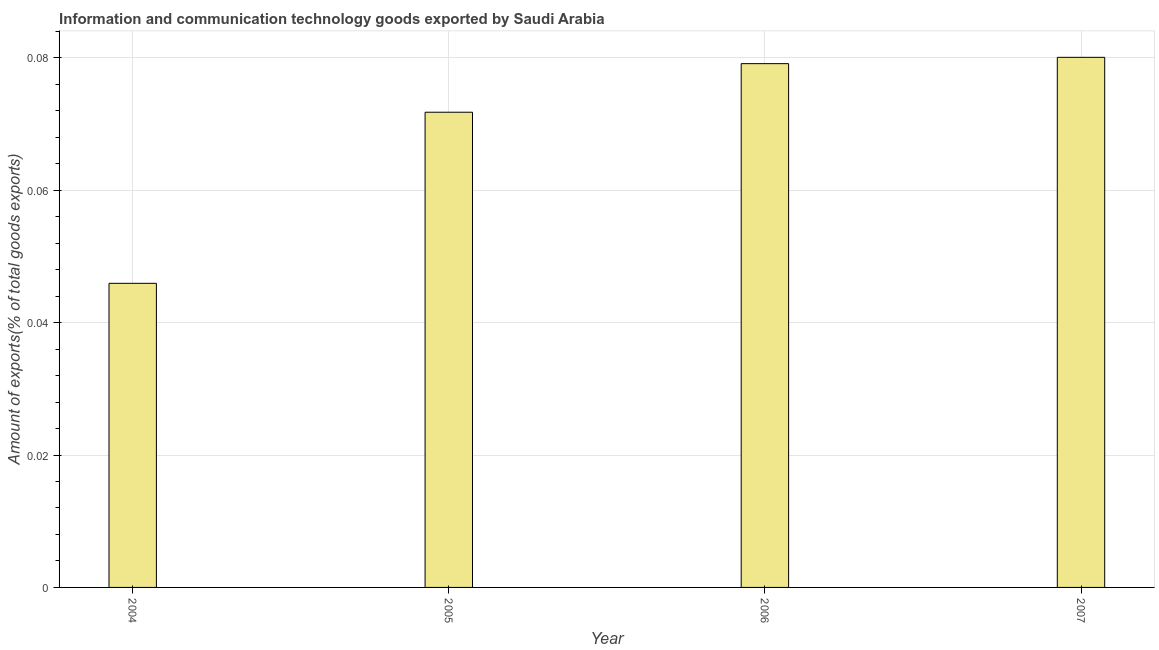Does the graph contain any zero values?
Your response must be concise. No. Does the graph contain grids?
Make the answer very short. Yes. What is the title of the graph?
Keep it short and to the point. Information and communication technology goods exported by Saudi Arabia. What is the label or title of the Y-axis?
Ensure brevity in your answer.  Amount of exports(% of total goods exports). What is the amount of ict goods exports in 2005?
Your answer should be compact. 0.07. Across all years, what is the maximum amount of ict goods exports?
Your response must be concise. 0.08. Across all years, what is the minimum amount of ict goods exports?
Ensure brevity in your answer.  0.05. In which year was the amount of ict goods exports maximum?
Provide a short and direct response. 2007. What is the sum of the amount of ict goods exports?
Make the answer very short. 0.28. What is the difference between the amount of ict goods exports in 2005 and 2007?
Offer a terse response. -0.01. What is the average amount of ict goods exports per year?
Offer a terse response. 0.07. What is the median amount of ict goods exports?
Your response must be concise. 0.08. In how many years, is the amount of ict goods exports greater than 0.072 %?
Offer a very short reply. 2. What is the ratio of the amount of ict goods exports in 2004 to that in 2007?
Offer a very short reply. 0.57. Is the difference between the amount of ict goods exports in 2005 and 2007 greater than the difference between any two years?
Keep it short and to the point. No. In how many years, is the amount of ict goods exports greater than the average amount of ict goods exports taken over all years?
Ensure brevity in your answer.  3. How many bars are there?
Ensure brevity in your answer.  4. Are all the bars in the graph horizontal?
Provide a succinct answer. No. What is the difference between two consecutive major ticks on the Y-axis?
Provide a succinct answer. 0.02. Are the values on the major ticks of Y-axis written in scientific E-notation?
Give a very brief answer. No. What is the Amount of exports(% of total goods exports) of 2004?
Offer a very short reply. 0.05. What is the Amount of exports(% of total goods exports) in 2005?
Keep it short and to the point. 0.07. What is the Amount of exports(% of total goods exports) of 2006?
Make the answer very short. 0.08. What is the Amount of exports(% of total goods exports) in 2007?
Offer a very short reply. 0.08. What is the difference between the Amount of exports(% of total goods exports) in 2004 and 2005?
Keep it short and to the point. -0.03. What is the difference between the Amount of exports(% of total goods exports) in 2004 and 2006?
Your response must be concise. -0.03. What is the difference between the Amount of exports(% of total goods exports) in 2004 and 2007?
Offer a terse response. -0.03. What is the difference between the Amount of exports(% of total goods exports) in 2005 and 2006?
Provide a succinct answer. -0.01. What is the difference between the Amount of exports(% of total goods exports) in 2005 and 2007?
Offer a terse response. -0.01. What is the difference between the Amount of exports(% of total goods exports) in 2006 and 2007?
Provide a succinct answer. -0. What is the ratio of the Amount of exports(% of total goods exports) in 2004 to that in 2005?
Offer a very short reply. 0.64. What is the ratio of the Amount of exports(% of total goods exports) in 2004 to that in 2006?
Make the answer very short. 0.58. What is the ratio of the Amount of exports(% of total goods exports) in 2004 to that in 2007?
Provide a short and direct response. 0.57. What is the ratio of the Amount of exports(% of total goods exports) in 2005 to that in 2006?
Provide a succinct answer. 0.91. What is the ratio of the Amount of exports(% of total goods exports) in 2005 to that in 2007?
Make the answer very short. 0.9. What is the ratio of the Amount of exports(% of total goods exports) in 2006 to that in 2007?
Give a very brief answer. 0.99. 